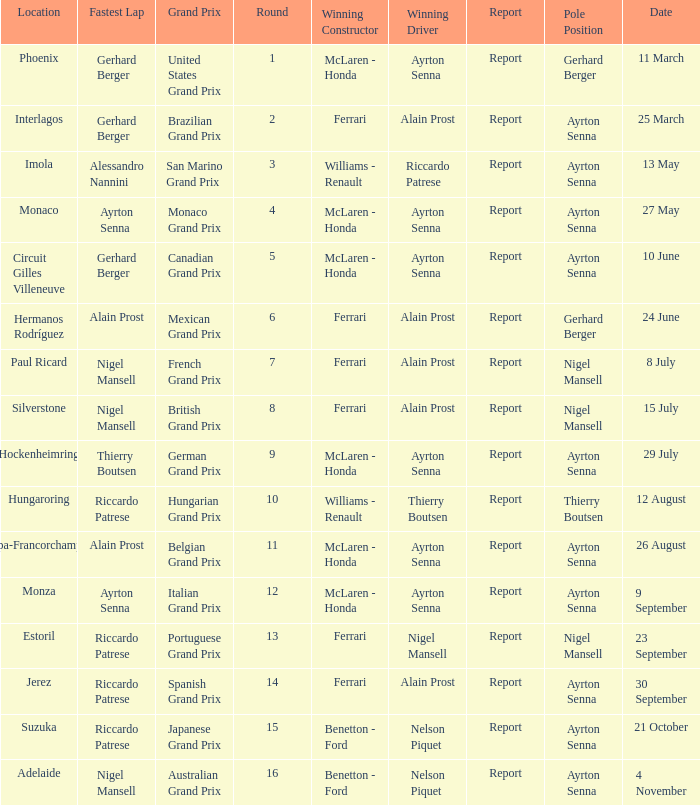What is the Pole Position for the German Grand Prix Ayrton Senna. 